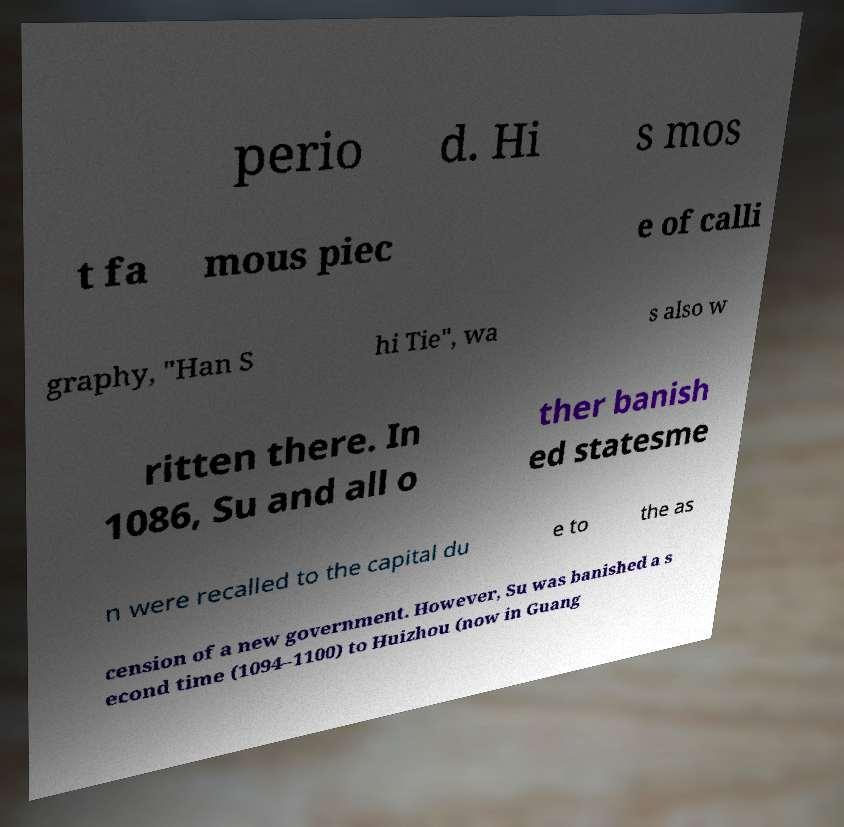Could you extract and type out the text from this image? perio d. Hi s mos t fa mous piec e of calli graphy, "Han S hi Tie", wa s also w ritten there. In 1086, Su and all o ther banish ed statesme n were recalled to the capital du e to the as cension of a new government. However, Su was banished a s econd time (1094–1100) to Huizhou (now in Guang 